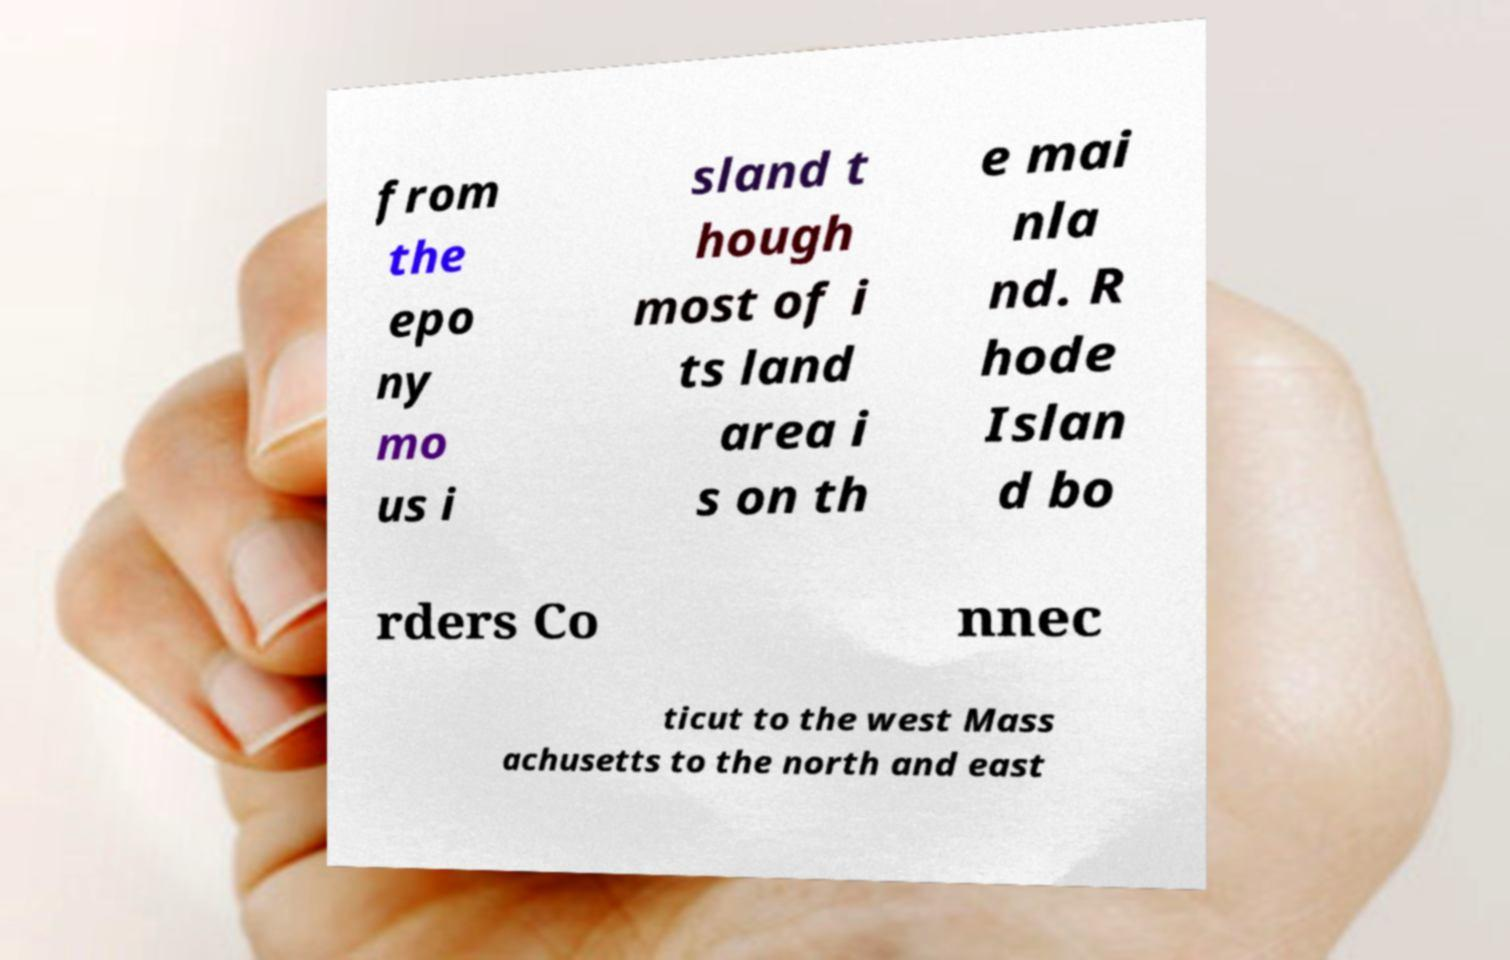Can you accurately transcribe the text from the provided image for me? from the epo ny mo us i sland t hough most of i ts land area i s on th e mai nla nd. R hode Islan d bo rders Co nnec ticut to the west Mass achusetts to the north and east 